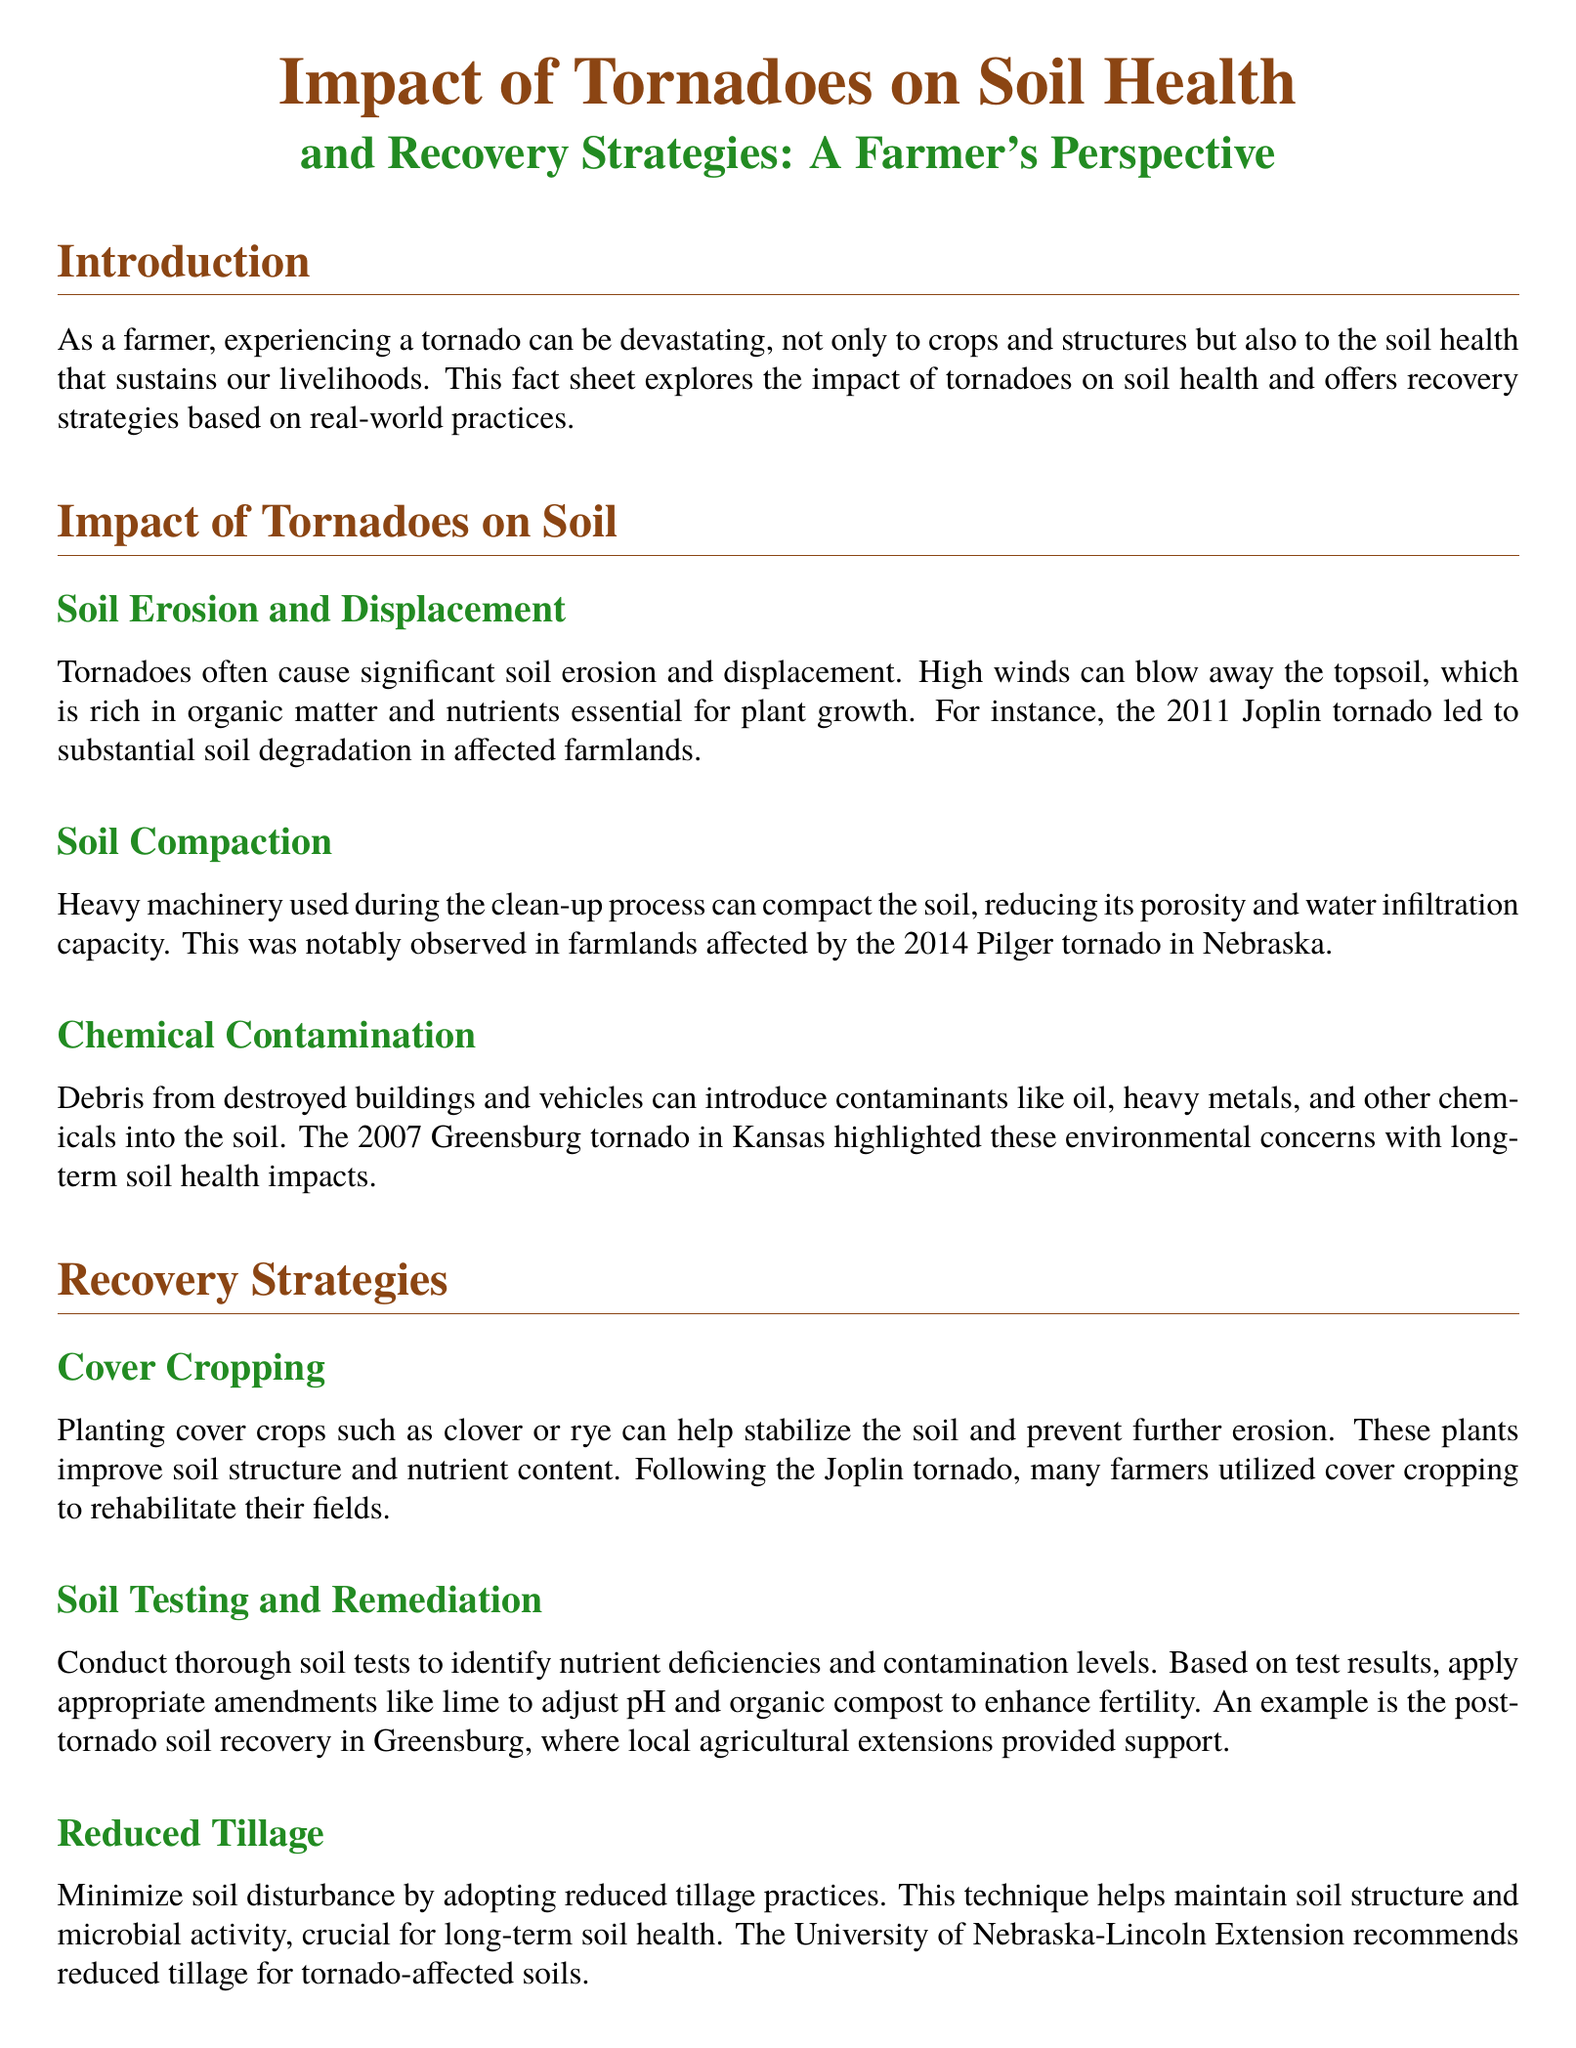What is the title of the document? The title of the document is the main heading that summarizes its content, which is "Impact of Tornadoes on Soil Health and Recovery Strategies: A Farmer's Perspective."
Answer: Impact of Tornadoes on Soil Health and Recovery Strategies: A Farmer's Perspective Which tornado is mentioned in relation to soil erosion and displacement? The Joplin tornado is highlighted in the document as an example of soil erosion and displacement resulting from tornado activity.
Answer: Joplin tornado What recovery strategy involves planting clover or rye? The document lists cover cropping as a strategy that involves planting specific crops to stabilize the soil after tornado damage.
Answer: Cover cropping What environmental issue is caused by debris from tornadoes? The debris from tornadoes can lead to chemical contamination of the soil, introducing harmful substances into the ground.
Answer: Chemical contamination Which tornado is associated with soil compaction due to heavy machinery? The text references the 2014 Pilger tornado in Nebraska as an instance where heavy machinery caused soil compaction.
Answer: 2014 Pilger tornado What is a recommended practice to help maintain soil structure? The document suggests reduced tillage as a recommended practice to help preserve soil integrity in the aftermath of tornadoes.
Answer: Reduced tillage Which organization is listed as a resource for soil recovery? The USDA Natural Resources Conservation Service (NRCS) is mentioned as a valuable resource for farmers dealing with soil recovery after tornadoes.
Answer: USDA Natural Resources Conservation Service (NRCS) What type of agricultural activity does the document emphasize for recovery after tornadoes? The main emphasis of the document is on soil health and recovery strategies, particularly after tornado events.
Answer: Soil health and recovery strategies 